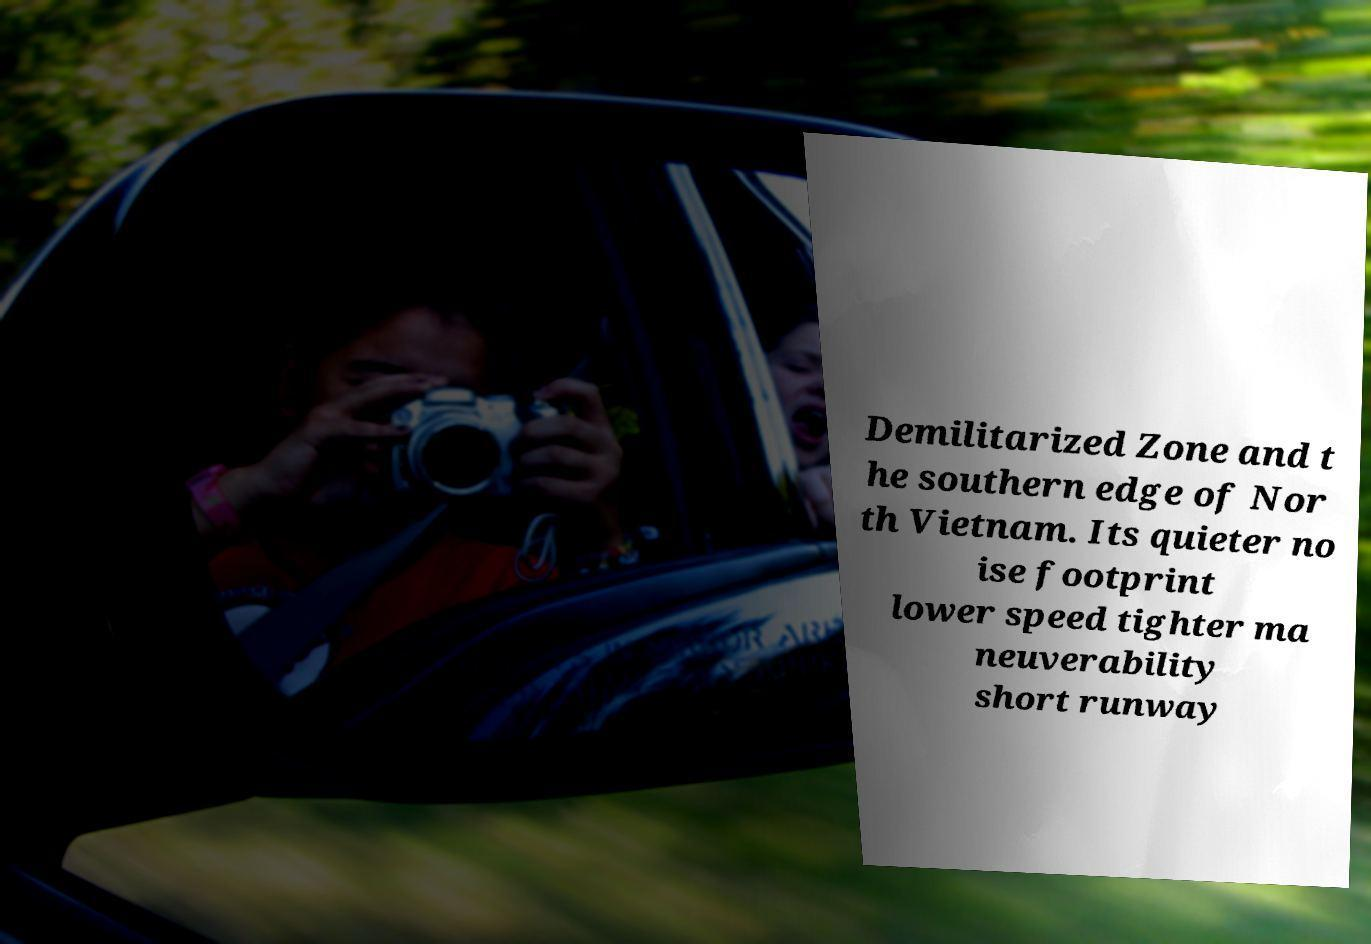For documentation purposes, I need the text within this image transcribed. Could you provide that? Demilitarized Zone and t he southern edge of Nor th Vietnam. Its quieter no ise footprint lower speed tighter ma neuverability short runway 